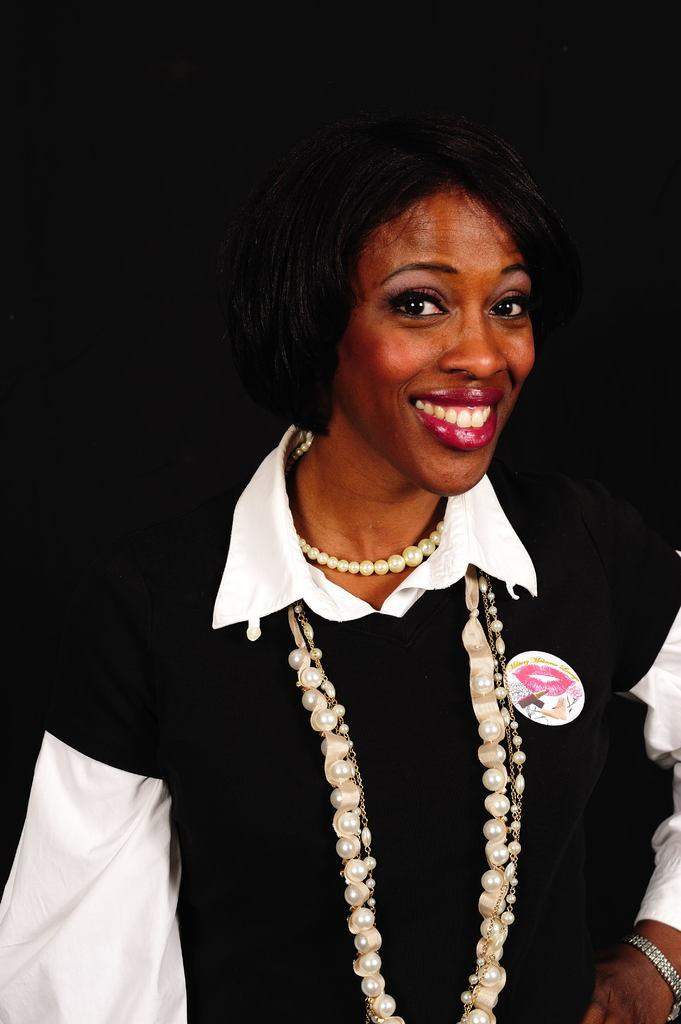What is the main subject of the image? The main subject of the image is a woman. Can you describe any accessories the woman is wearing? The woman is wearing jewelry in the image. What type of soup is the woman eating in the image? There is no soup present in the image; the woman is wearing jewelry. What is the woman using to draw in the image? There is no pencil or drawing activity present in the image; the woman is wearing jewelry. 